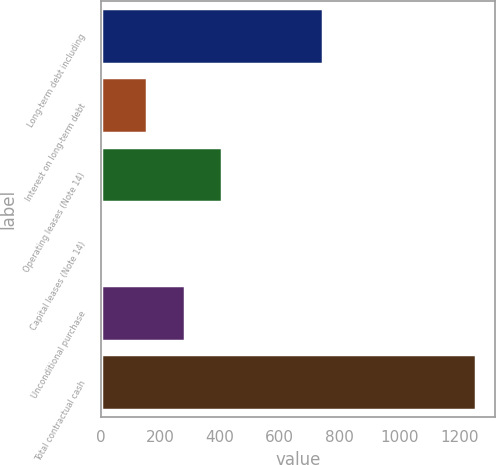<chart> <loc_0><loc_0><loc_500><loc_500><bar_chart><fcel>Long-term debt including<fcel>Interest on long-term debt<fcel>Operating leases (Note 14)<fcel>Capital leases (Note 14)<fcel>Unconditional purchase<fcel>Total contractual cash<nl><fcel>744<fcel>157<fcel>407.4<fcel>6<fcel>282.2<fcel>1258<nl></chart> 